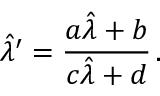Convert formula to latex. <formula><loc_0><loc_0><loc_500><loc_500>\hat { \lambda } ^ { \prime } = \frac { a \hat { \lambda } + b } { c \hat { \lambda } + d } \, .</formula> 